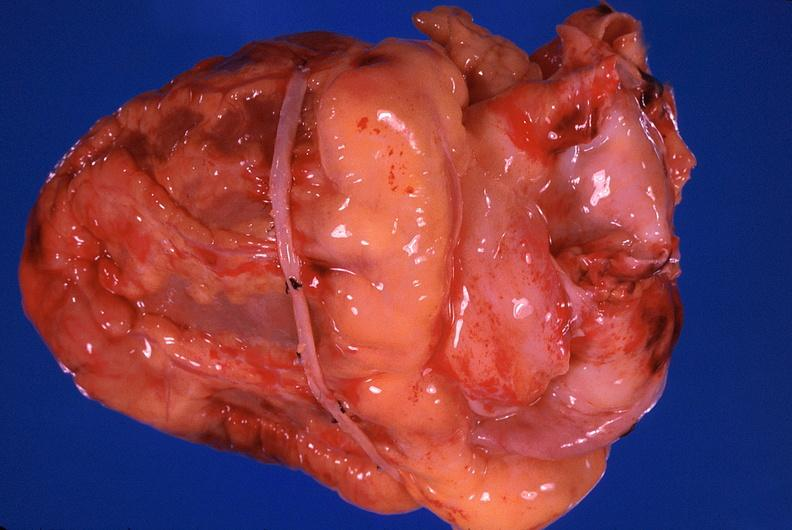s cardiovascular present?
Answer the question using a single word or phrase. Yes 